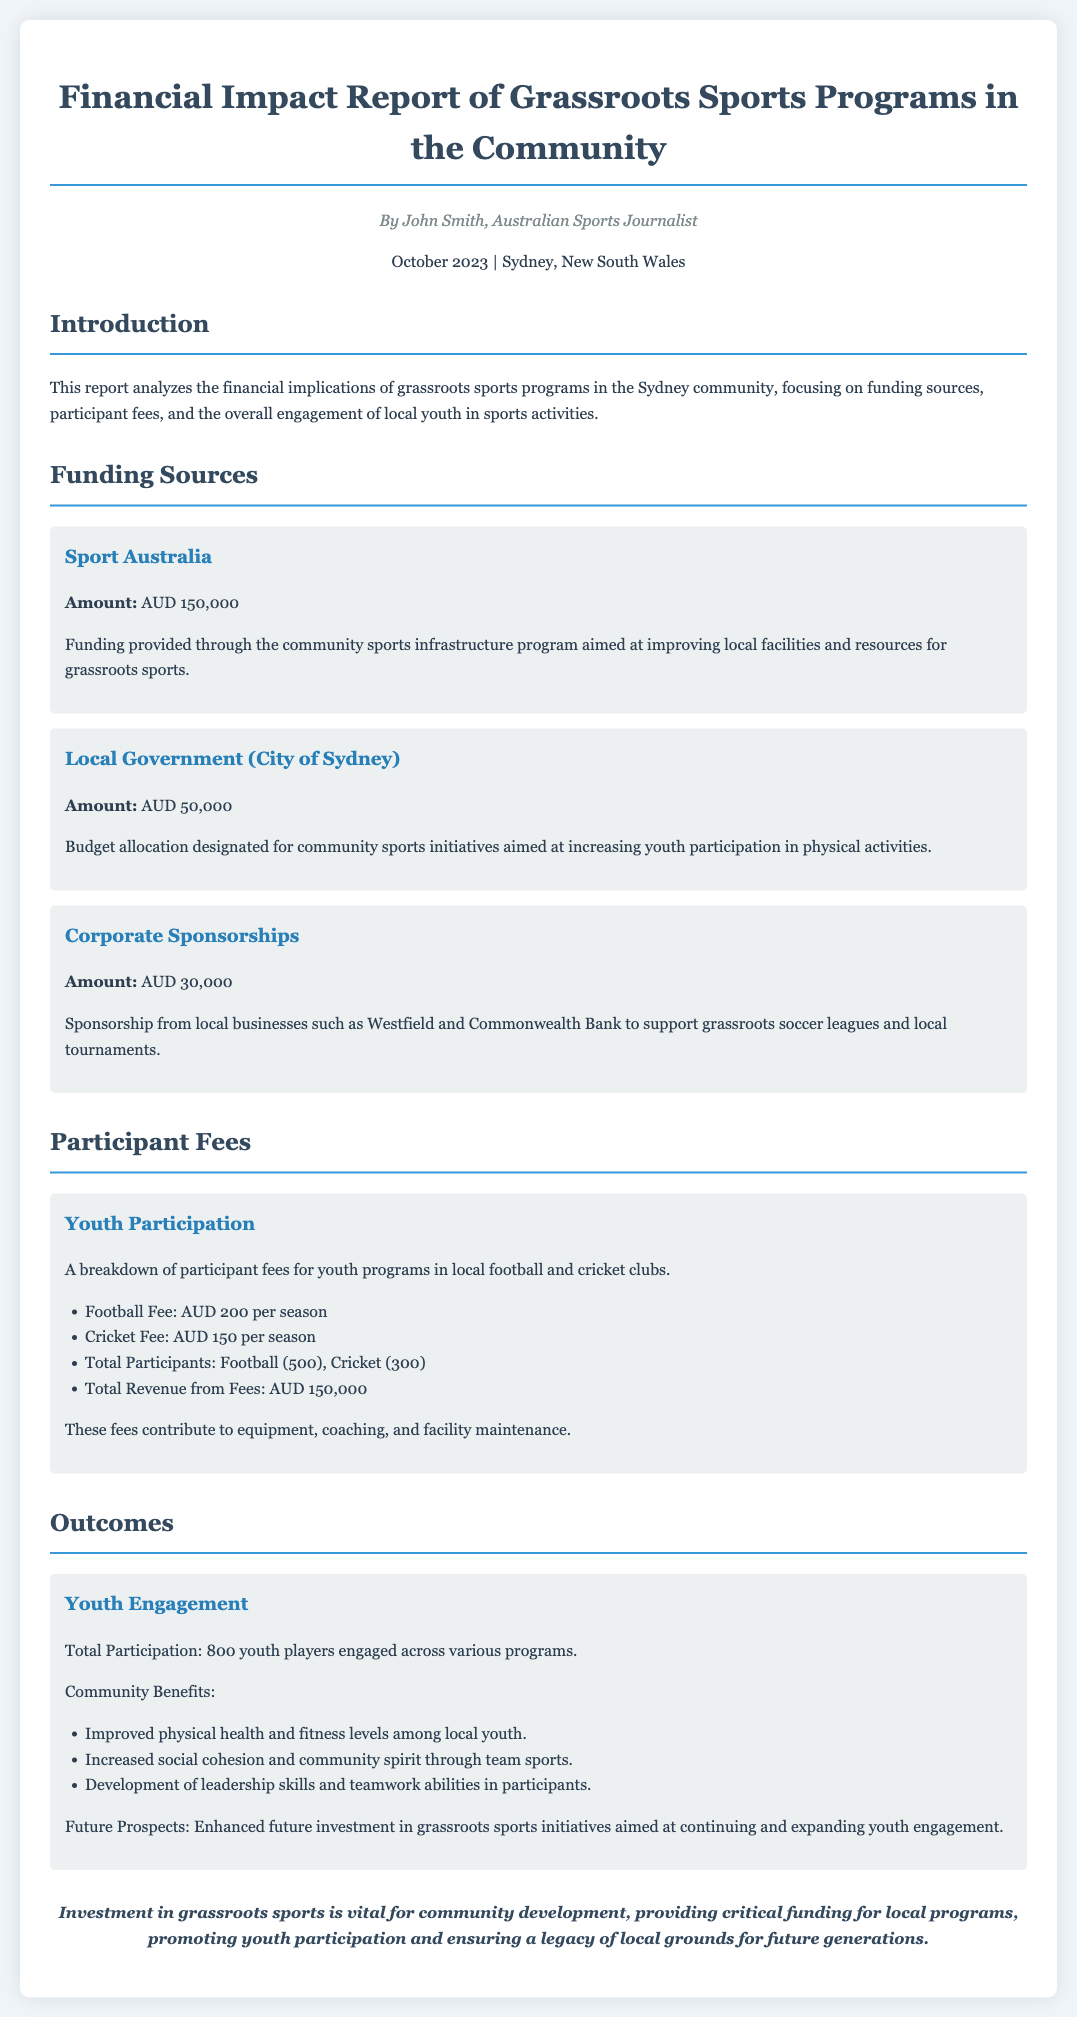what is the total amount funded by Sport Australia? The funding amount provided by Sport Australia is detailed in the document.
Answer: AUD 150,000 what is the participant fee for cricket? The document explicitly states the fee for youth cricket programs.
Answer: AUD 150 per season how many total youth players are engaged in the programs? The total participation figure is mentioned in the outcomes section.
Answer: 800 youth players what is the funding amount from Corporate Sponsorships? The amount from corporate sponsorships is listed in the funding sources section.
Answer: AUD 30,000 what community benefits are mentioned in the outcomes? The document lists various benefits; one key benefit is improved physical health among youth.
Answer: Improved physical health and fitness levels what is the total revenue from participants' fees? The document provides a specific figure that represents total revenue from participant fees.
Answer: AUD 150,000 what is the funding amount from the City of Sydney? The document clearly indicates the funding amount provided by the local government.
Answer: AUD 50,000 what are the future prospects mentioned in the report? The report briefly outlines upcoming investments aimed at youth engagement.
Answer: Enhanced future investment in grassroots sports initiatives 